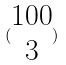Convert formula to latex. <formula><loc_0><loc_0><loc_500><loc_500>( \begin{matrix} 1 0 0 \\ 3 \end{matrix} )</formula> 